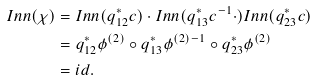<formula> <loc_0><loc_0><loc_500><loc_500>I n n ( \chi ) & = I n n ( q _ { 1 2 } ^ { \ast } c ) \cdot I n n ( q _ { 1 3 } ^ { \ast } c ^ { - 1 } \cdot ) I n n ( q _ { 2 3 } ^ { \ast } c ) \\ & = q _ { 1 2 } ^ { \ast } \phi ^ { ( 2 ) } \circ q _ { 1 3 } ^ { \ast } \phi ^ { ( 2 ) - 1 } \circ q _ { 2 3 } ^ { \ast } \phi ^ { ( 2 ) } \\ & = i d .</formula> 